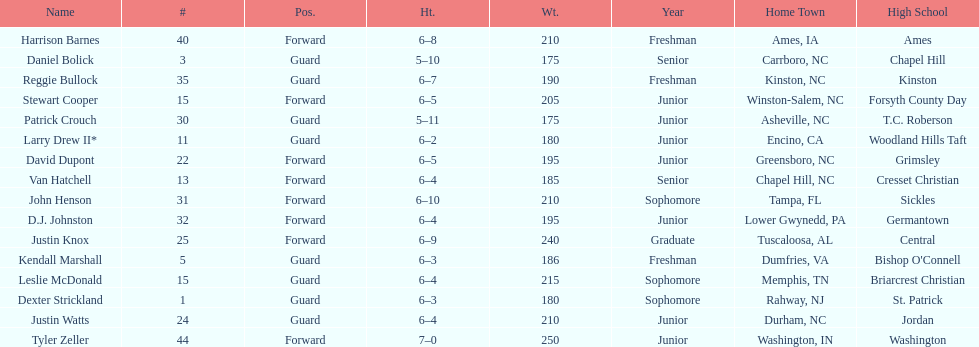How many players play a position other than guard? 8. 